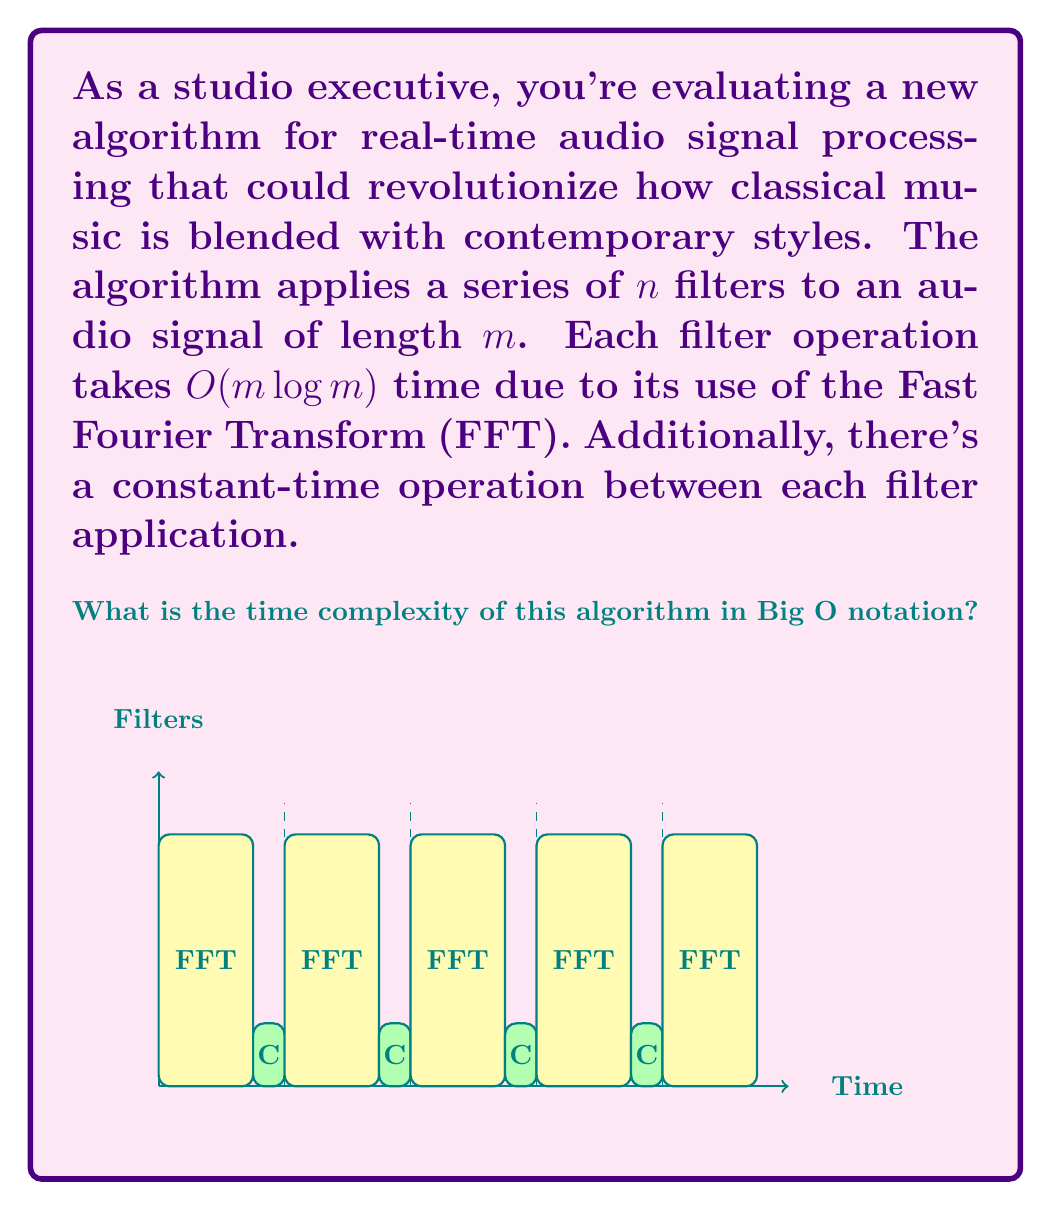Could you help me with this problem? Let's analyze this algorithm step-by-step:

1) We have $n$ filters being applied to an audio signal of length $m$.

2) Each filter operation uses the Fast Fourier Transform (FFT), which has a time complexity of $O(m \log m)$.

3) Between each filter application, there's a constant-time operation. Let's call this time $c$.

4) The total time for the algorithm can be expressed as:

   $T(n,m) = n \cdot O(m \log m) + (n-1) \cdot O(1)$

5) Simplifying:
   $T(n,m) = n \cdot O(m \log m) + O(n)$

6) The $O(n)$ term is dominated by $n \cdot O(m \log m)$ for large values of $m$ and $n$, so we can drop it:

   $T(n,m) = n \cdot O(m \log m)$

7) Distributing the $n$:

   $T(n,m) = O(nm \log m)$

This is the final time complexity of the algorithm.

Note: In Big O notation, we're concerned with the upper bound of the growth rate. The constant-time operations between filters don't affect this upper bound for large inputs, which is why they don't appear in the final expression.
Answer: $O(nm \log m)$ 